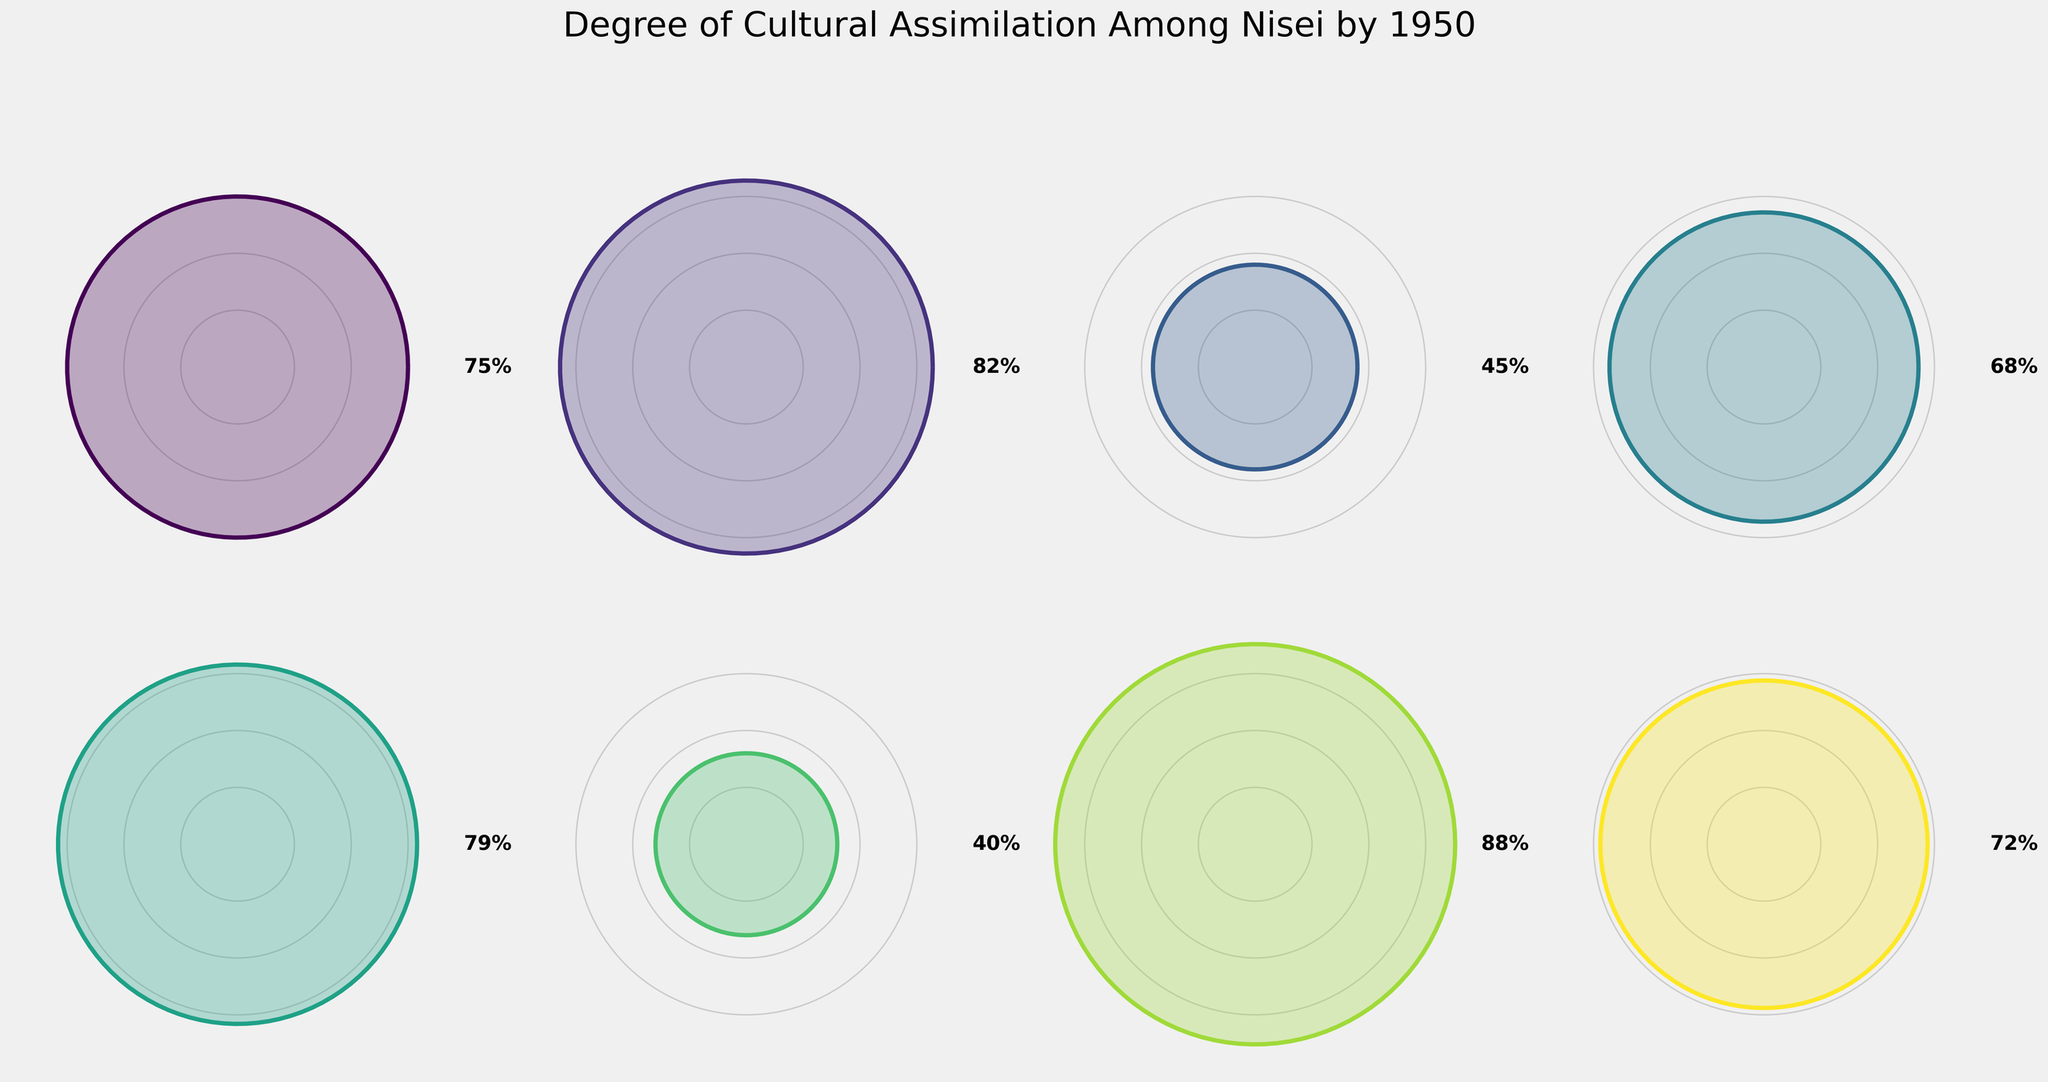What is the title of the figure? The title is generally displayed at the top of the figure. Here, it is easy to locate as it is big and prominently placed.
Answer: Degree of Cultural Assimilation Among Nisei by 1950 What is the proficiency rate in American Cultural Knowledge? Locate the section labeled 'American Cultural Knowledge' and check the percentage value displayed there.
Answer: 82% Which category has the lowest value? Compare all the values across different categories and identify the one with the smallest percentage.
Answer: Retention of Japanese Traditions What is the sum of the values for Language Proficiency and Educational Integration? Add the values associated with both categories: Language Proficiency (75%) and Educational Integration (88%).
Answer: 163% Which categories have values greater than 75%? Scan through the values in each category and list those with percentages higher than 75%.
Answer: Language Proficiency, American Cultural Knowledge, Adoption of American Customs, Educational Integration What is the average value of all the categories? Sum up all the values and then divide by the number of categories. (75 + 82 + 45 + 68 + 79 + 40 + 88 + 72) / 8 = 549 / 8 = 68.625
Answer: 68.625% How does the Intermarriage Rate compare to the Participation in Mainstream Organizations? Compare the percentage values of both categories: Intermarriage Rate (45%) and Participation in Mainstream Organizations (68%).
Answer: Intermarriage Rate is lower What is the difference between Employment in Non-Japanese Businesses and Retention of Japanese Traditions? Subtract the value of Retention of Japanese Traditions (40%) from Employment in Non-Japanese Businesses (72%).
Answer: 32% Which category shows greater assimilation, Adoption of American Customs or Intermarriage Rate? Compare percentages of both categories: Adoption of American Customs (79%) and Intermarriage Rate (45%).
Answer: Adoption of American Customs 